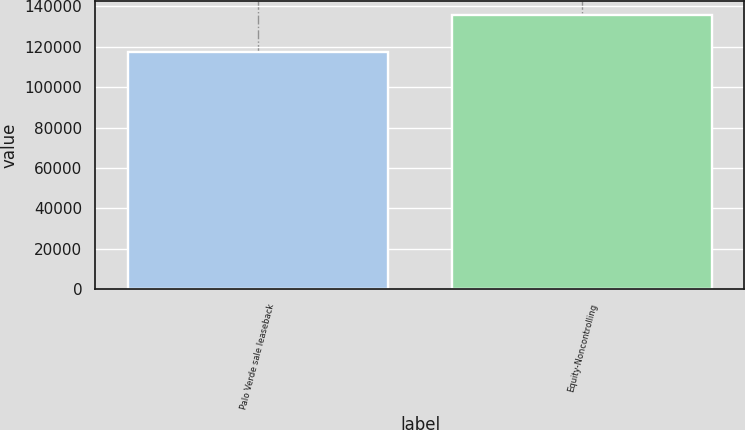<chart> <loc_0><loc_0><loc_500><loc_500><bar_chart><fcel>Palo Verde sale leaseback<fcel>Equity-Noncontrolling<nl><fcel>117385<fcel>135540<nl></chart> 